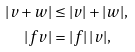Convert formula to latex. <formula><loc_0><loc_0><loc_500><loc_500>| v + w | & \leq | v | + | w | , \\ | f v | & = | f | \, | v | ,</formula> 